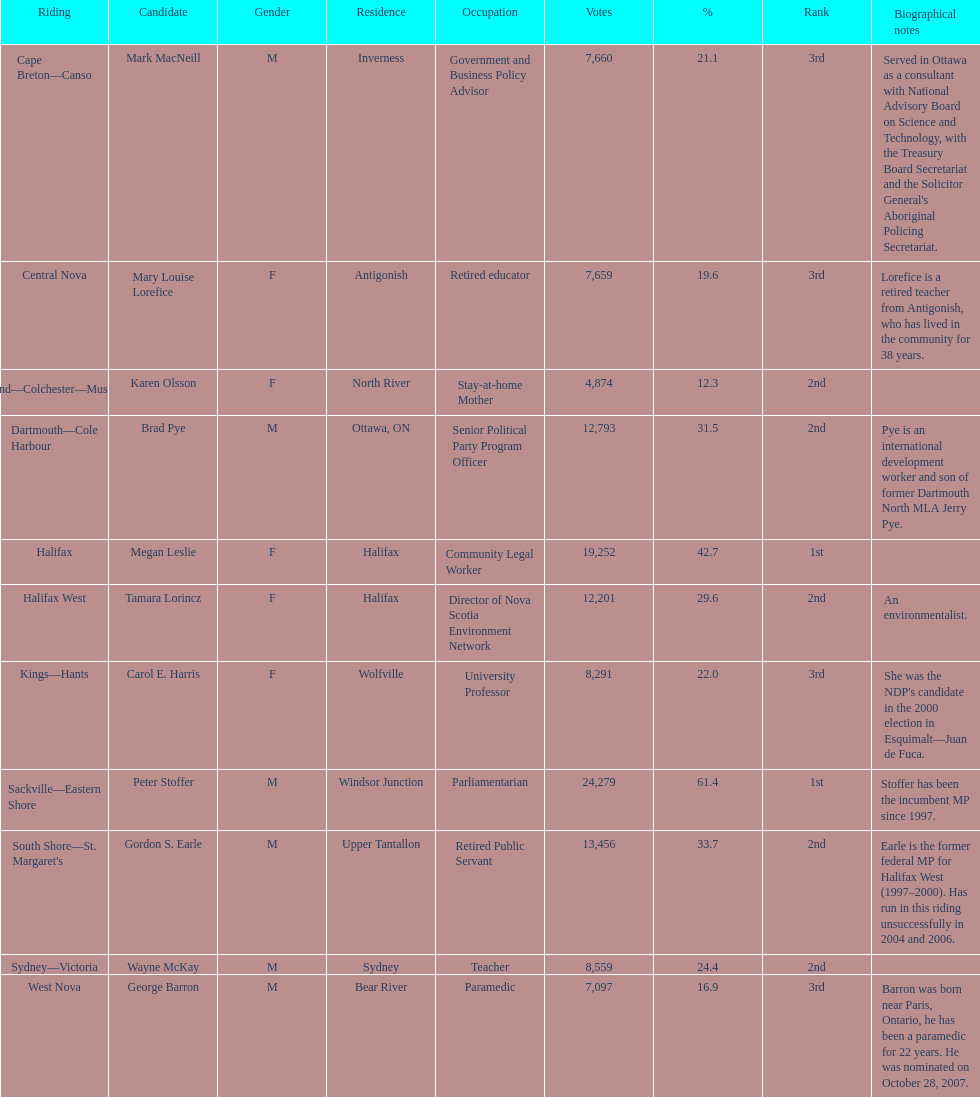How many of the candidates were females? 5. 